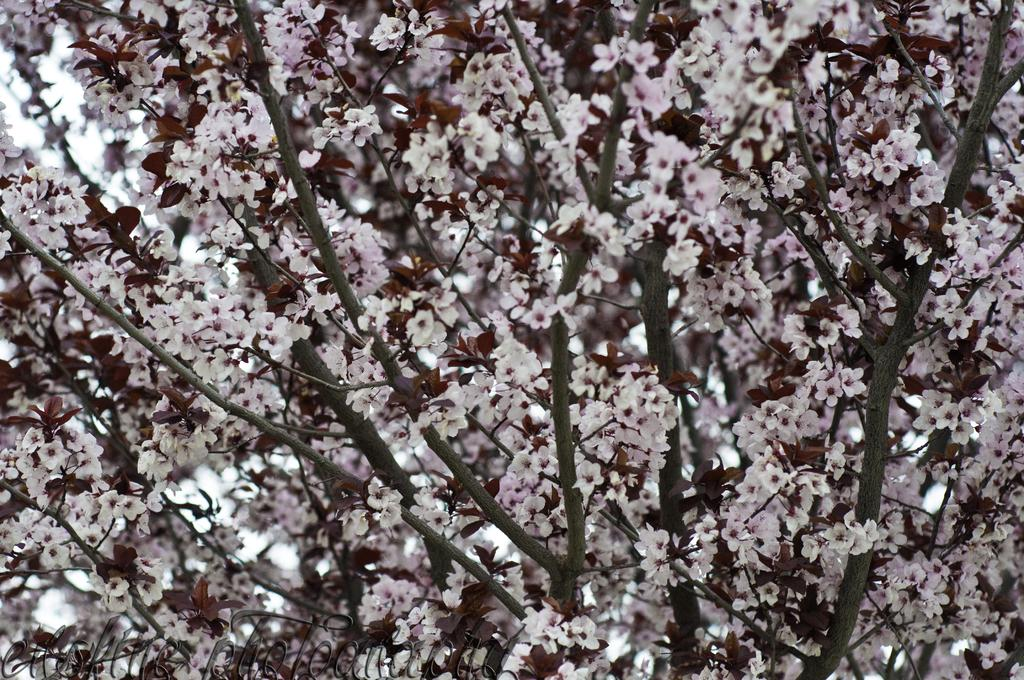What type of vegetation can be seen in the image? There are branches and flowers in the image. Can you describe the branches in the image? The branches are part of the vegetation depicted in the image. What other elements can be seen in the image besides the branches? There are flowers in the image. What type of net is being used to catch the flowers in the image? There is no net present in the image; it only features branches and flowers. Is there a meeting taking place in the image? There is no indication of a meeting in the image; it only features branches and flowers. 